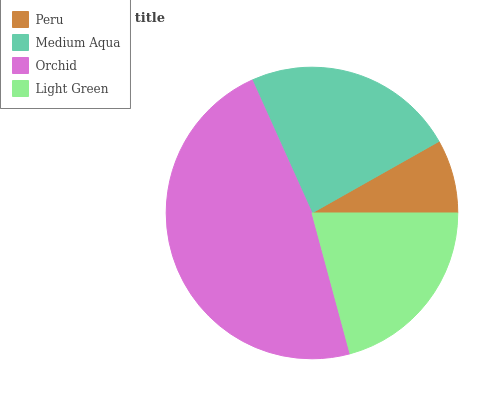Is Peru the minimum?
Answer yes or no. Yes. Is Orchid the maximum?
Answer yes or no. Yes. Is Medium Aqua the minimum?
Answer yes or no. No. Is Medium Aqua the maximum?
Answer yes or no. No. Is Medium Aqua greater than Peru?
Answer yes or no. Yes. Is Peru less than Medium Aqua?
Answer yes or no. Yes. Is Peru greater than Medium Aqua?
Answer yes or no. No. Is Medium Aqua less than Peru?
Answer yes or no. No. Is Medium Aqua the high median?
Answer yes or no. Yes. Is Light Green the low median?
Answer yes or no. Yes. Is Orchid the high median?
Answer yes or no. No. Is Peru the low median?
Answer yes or no. No. 